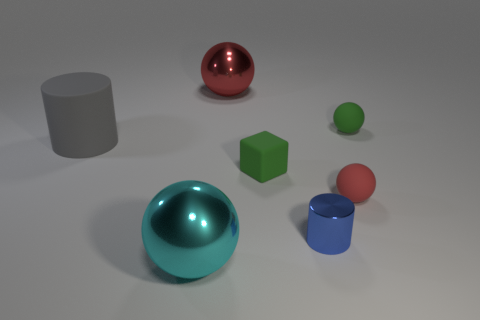Subtract all yellow blocks. How many red spheres are left? 2 Add 3 large red shiny balls. How many objects exist? 10 Subtract all blue balls. Subtract all gray blocks. How many balls are left? 4 Subtract all cylinders. How many objects are left? 5 Add 4 blue metallic cylinders. How many blue metallic cylinders are left? 5 Add 7 red metal objects. How many red metal objects exist? 8 Subtract 0 brown blocks. How many objects are left? 7 Subtract all gray matte cylinders. Subtract all gray rubber cylinders. How many objects are left? 5 